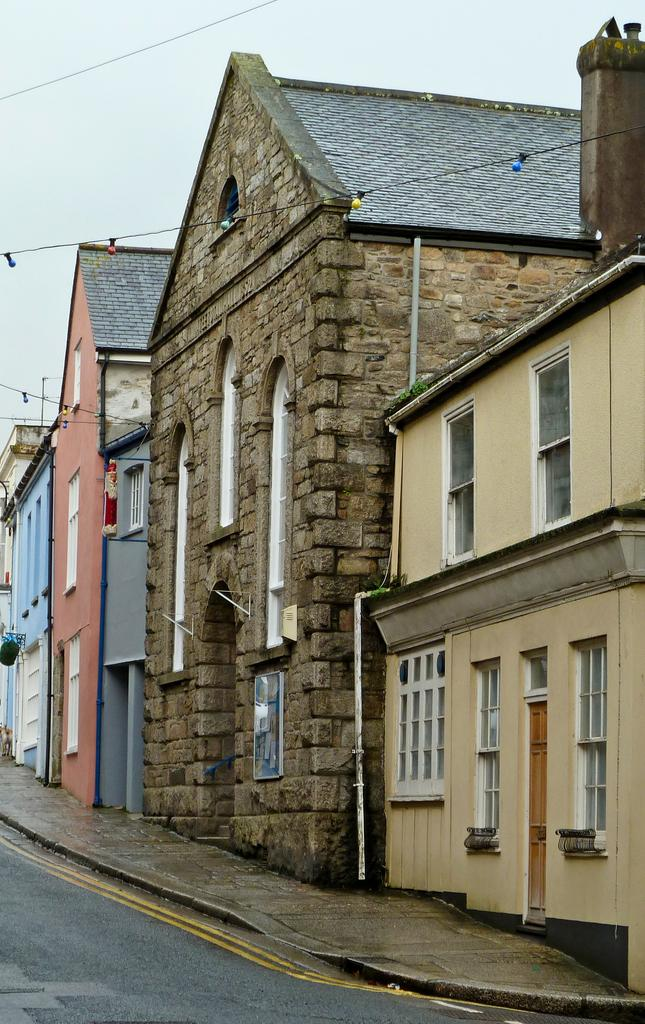What type of structures can be seen in the image? There are buildings in the image. Where is the road located in the image? The road is at the bottom left corner of the image. What part of the natural environment is visible in the image? The sky is visible in the background of the image. How many people have died in the image? There is no indication of any deaths in the image, as it primarily features buildings, a road, and the sky. 